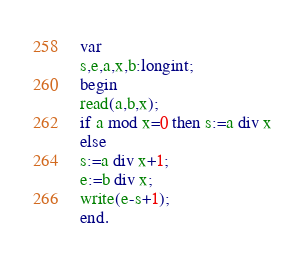<code> <loc_0><loc_0><loc_500><loc_500><_Pascal_>var
s,e,a,x,b:longint;
begin
read(a,b,x);
if a mod x=0 then s:=a div x
else
s:=a div x+1;
e:=b div x;
write(e-s+1);
end.
</code> 